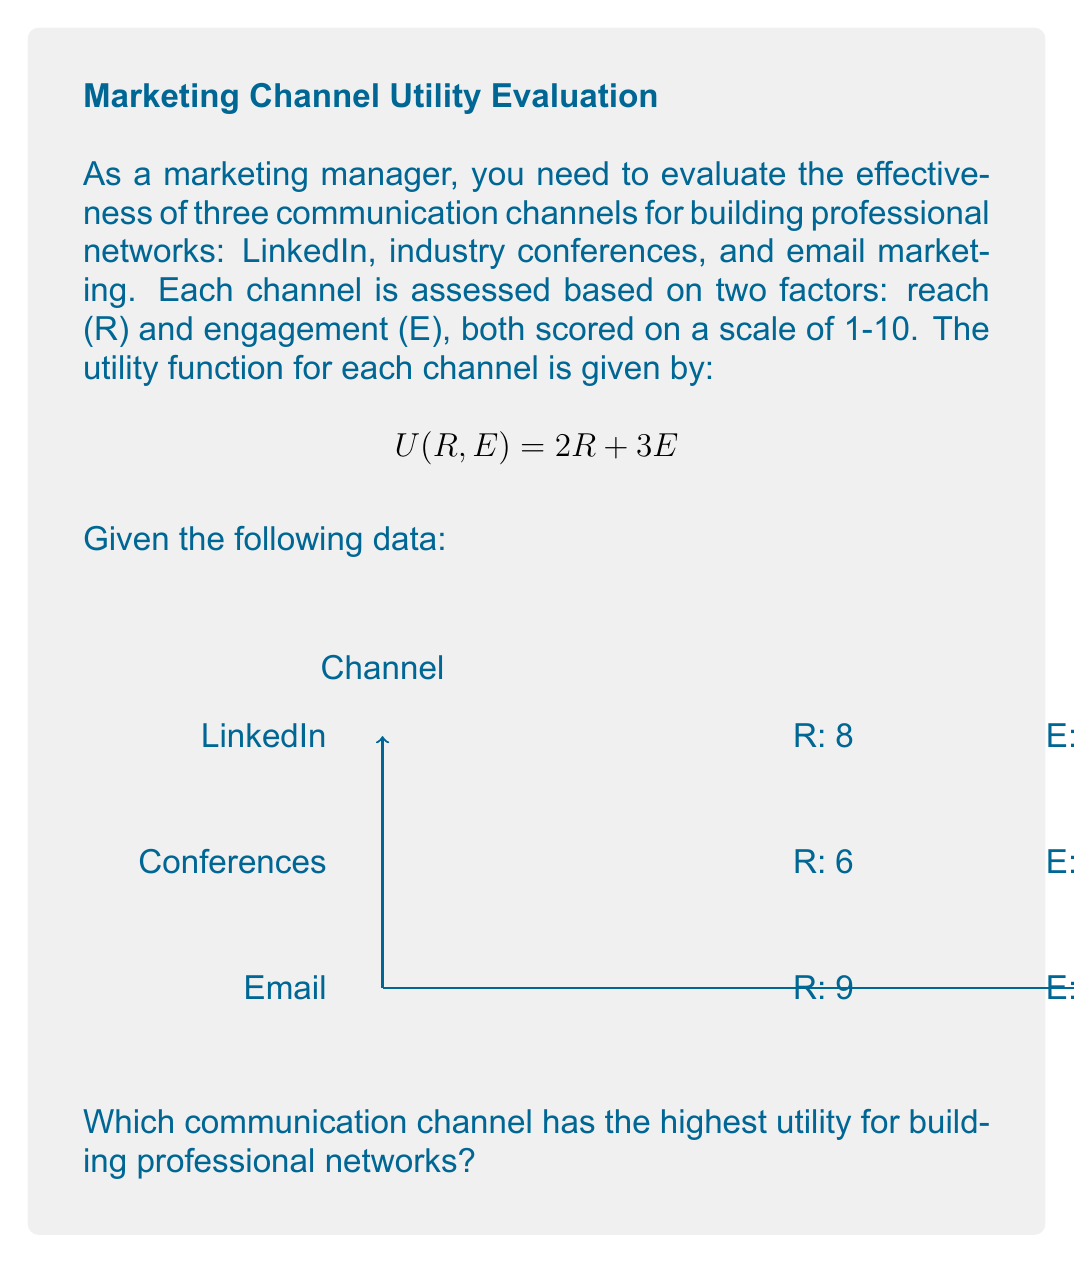Provide a solution to this math problem. To solve this problem, we need to calculate the utility for each communication channel using the given utility function and data. Let's go through it step-by-step:

1. Utility function: $U(R, E) = 2R + 3E$

2. Calculate utility for LinkedIn:
   $R = 8, E = 7$
   $U_{LinkedIn} = 2(8) + 3(7) = 16 + 21 = 37$

3. Calculate utility for industry conferences:
   $R = 6, E = 9$
   $U_{Conferences} = 2(6) + 3(9) = 12 + 27 = 39$

4. Calculate utility for email marketing:
   $R = 9, E = 5$
   $U_{Email} = 2(9) + 3(5) = 18 + 15 = 33$

5. Compare the utilities:
   LinkedIn: 37
   Conferences: 39
   Email: 33

The highest utility is 39, which corresponds to industry conferences.
Answer: Industry conferences 